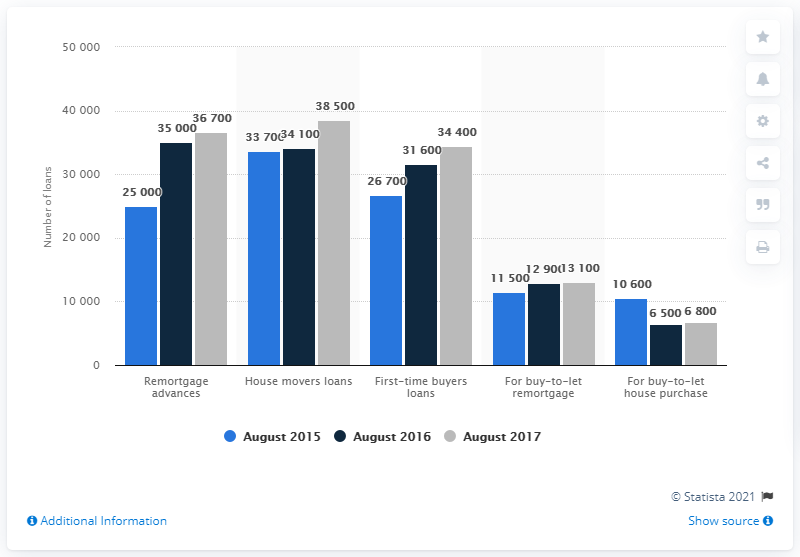Highlight a few significant elements in this photo. As of August 2017, a total of 38,500 loans were provided for home movers. 